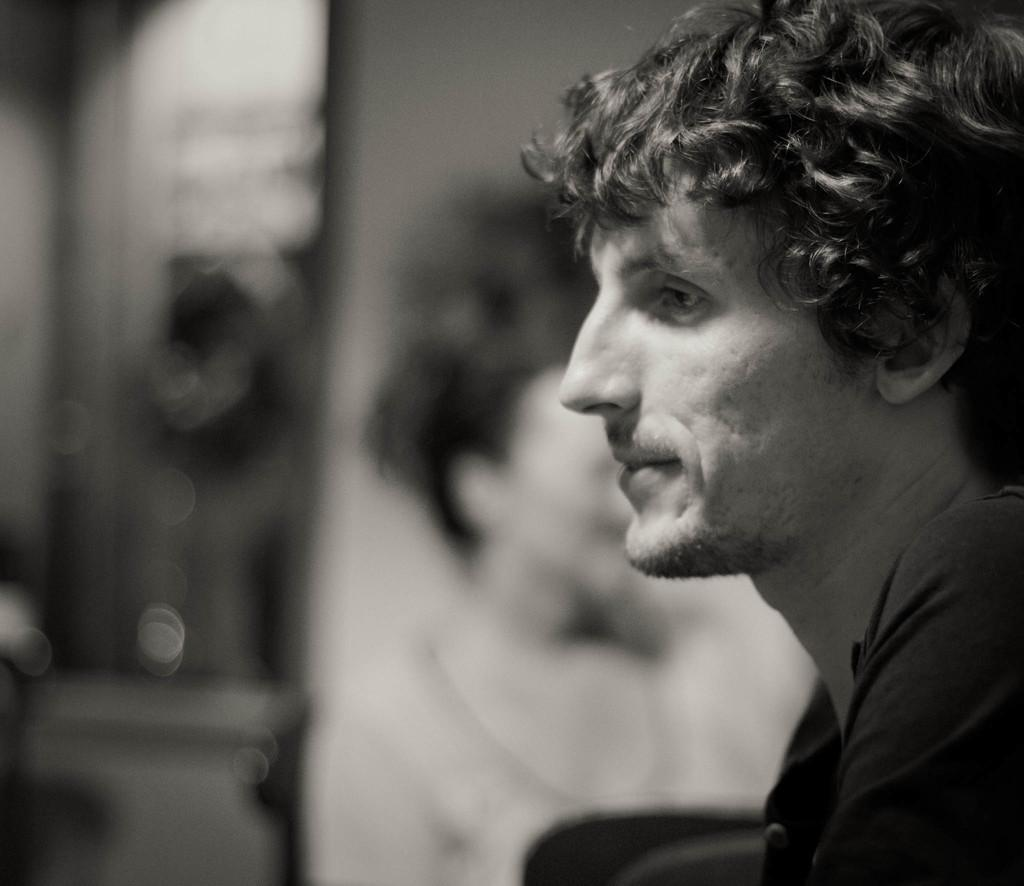What is the primary subject of the picture? There is a man in the picture. Can you describe the woman's position in relation to the man? There appears to be a woman beside the man in the picture. What type of bone can be seen in the picture? There is no bone present in the picture; it features a man and a woman. What kind of cake is being served in the picture? There is no cake present in the picture; it only shows a man and a woman. 